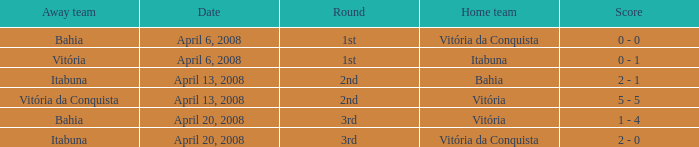Help me parse the entirety of this table. {'header': ['Away team', 'Date', 'Round', 'Home team', 'Score'], 'rows': [['Bahia', 'April 6, 2008', '1st', 'Vitória da Conquista', '0 - 0'], ['Vitória', 'April 6, 2008', '1st', 'Itabuna', '0 - 1'], ['Itabuna', 'April 13, 2008', '2nd', 'Bahia', '2 - 1'], ['Vitória da Conquista', 'April 13, 2008', '2nd', 'Vitória', '5 - 5'], ['Bahia', 'April 20, 2008', '3rd', 'Vitória', '1 - 4'], ['Itabuna', 'April 20, 2008', '3rd', 'Vitória da Conquista', '2 - 0']]} What is the name of the home team on April 13, 2008 when Itabuna was the away team? Bahia. 